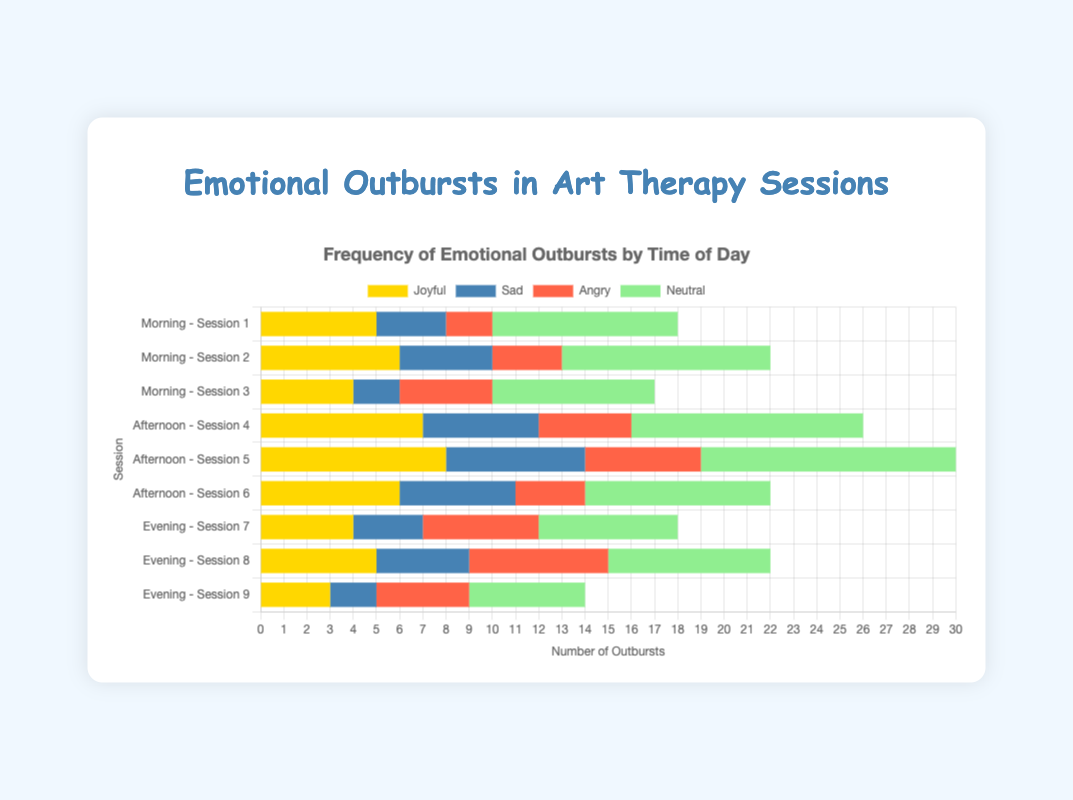Which time of day shows the highest number of Joyful outbursts? To answer this question, we need to observe each bar representing "Joyful" across all time segments (Morning, Afternoon, Evening) and identify the maximum. Afternoon has the highest Joyful outburst with 8 in Session 5, higher than both Morning and Evening sessions.
Answer: Afternoon Which session had the highest total number of outbursts (Joyful, Sad, Angry, and Neutral combined)? To answer this, sum up all outbursts for each session individually and find the maximum. Session 5 has a total of 8 (Joyful) + 6 (Sad) + 5 (Angry) + 11 (Neutral) = 30, which is the highest.
Answer: Session 5 Compare the total number of Sad outbursts between Morning and Evening sessions. Which has more? Sum all Sad outbursts for both Morning and Evening segments. Morning has 3 + 4 + 2 = 9 and Evening has 3 + 4 + 2 = 9. Both are equal.
Answer: Equal Considering the average number of Neutral outbursts per session in the Afternoon, what is the result? The total number of Neutral outbursts in the Afternoon is 10 + 11 + 8 = 29. There are 3 sessions in the Afternoon. Therefore, the average is 29 / 3 ≈ 9.67.
Answer: 9.67 Which emotion shows the greatest increase from Morning to Afternoon sessions? Compute the differences in totals from Morning to Afternoon for each emotion. Joyful: (21 - 15) = 6, Sad: (16 - 9) = 7, Angry: (12 - 9) = 3, Neutral: (29 - 24) = 5. Sad shows the greatest increase.
Answer: Sad Which session shows the least number of Neutral outbursts? Compare the Neutral bars' lengths across all sessions. Session 9 has the least Neutral outbursts with a value of 5.
Answer: Session 9 What is the combined number of Angry outbursts for all Evening sessions? Sum the Angry outbursts for all Evening sessions: 5 + 6 + 4 = 15.
Answer: 15 Are there more Joyful or Angry outbursts in Session 4? Compare Joyful and Angry values in Session 4. Joyful has 7, and Angry has 4, so there are more Joyful outbursts.
Answer: Joyful Calculate the difference in Neutral outbursts between Session 2 and Session 6. Session 2 has 9 Neutral outbursts, and Session 6 has 8. The difference is 9 - 8 = 1.
Answer: 1 In which time of day do the teenagers exhibit more Neutral than Joyful outbursts in all sessions? Compare Neutral and Joyful outbursts in all sessions within a time segment. In Morning sessions, Neutral outbursts (8, 9, 7) are consistently more than Joyful (5, 6, 4).
Answer: Morning 